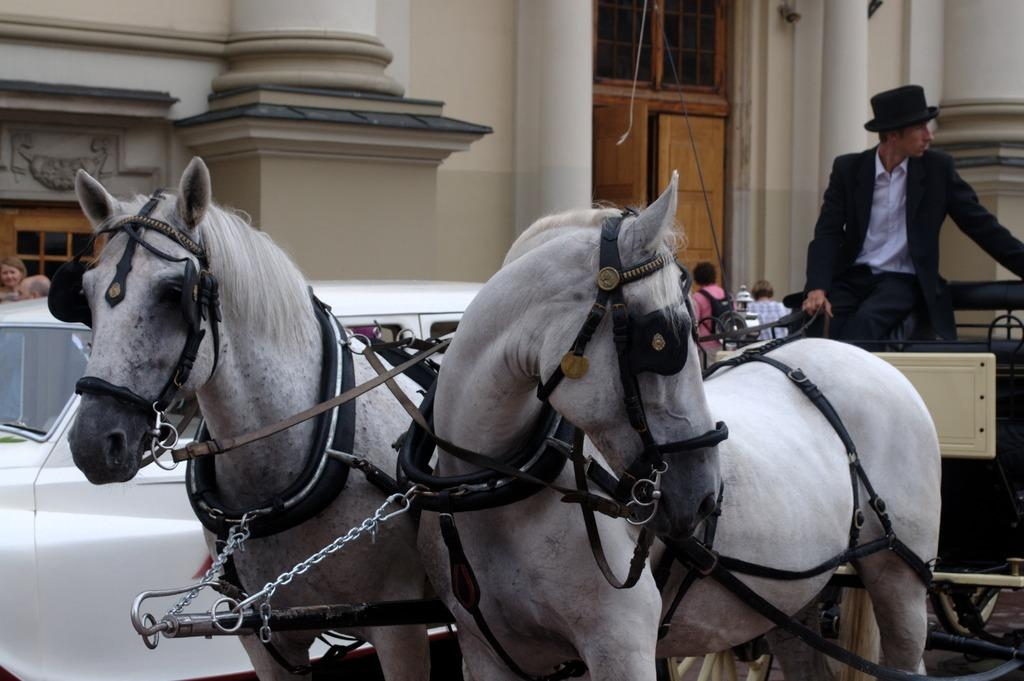How many horses are in the image? There are two horses in the image. What is happening with the horses? One person is riding the horses. What can be seen in the background of the image? There are cars, people, and a building in the background of the image. What type of hour can be seen on the seashore in the image? There is no hour or seashore present in the image; it features two horses with one person riding them, along with a background that includes cars, people, and a building. 